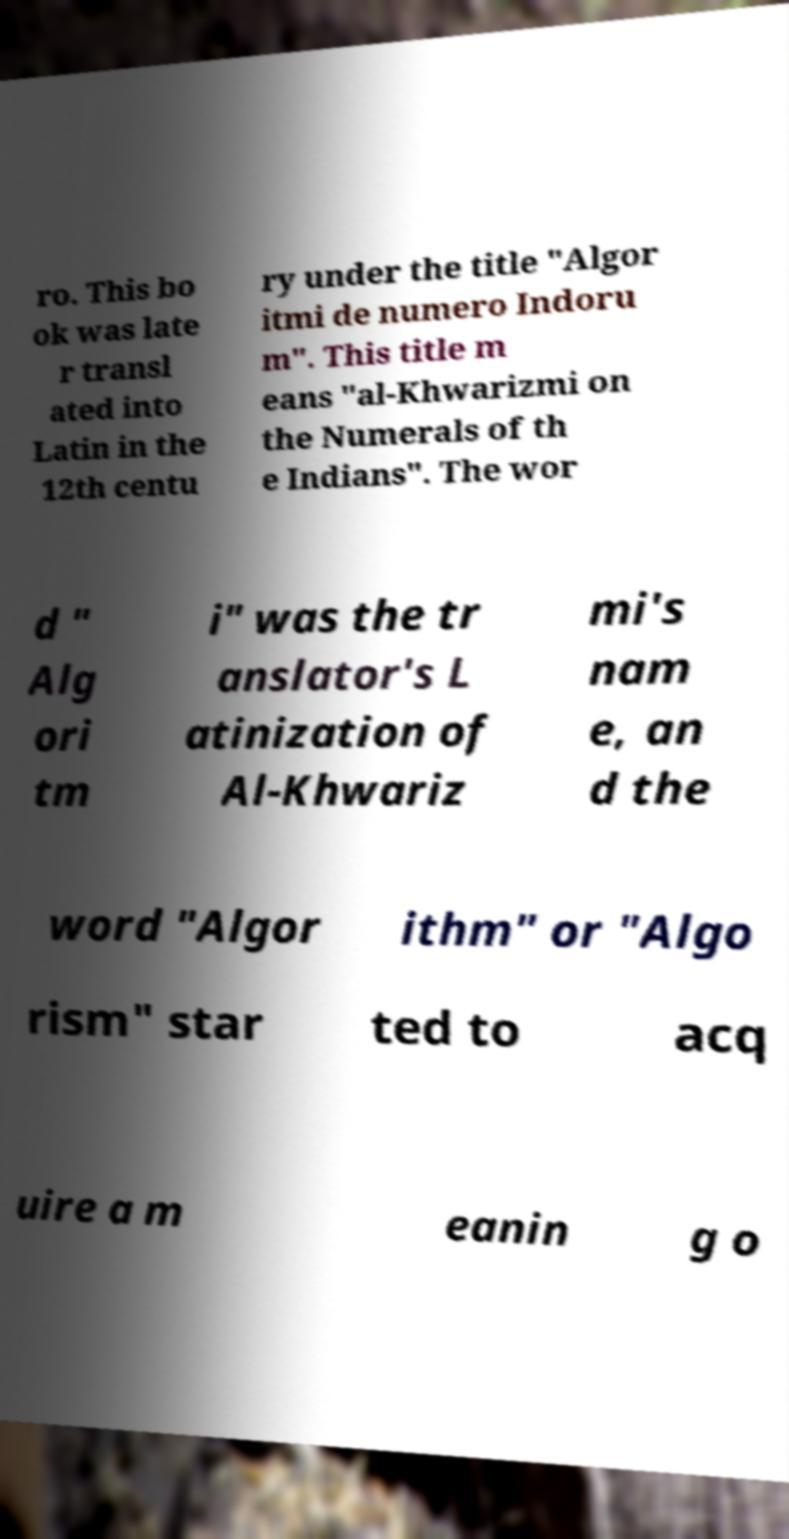There's text embedded in this image that I need extracted. Can you transcribe it verbatim? ro. This bo ok was late r transl ated into Latin in the 12th centu ry under the title "Algor itmi de numero Indoru m". This title m eans "al-Khwarizmi on the Numerals of th e Indians". The wor d " Alg ori tm i" was the tr anslator's L atinization of Al-Khwariz mi's nam e, an d the word "Algor ithm" or "Algo rism" star ted to acq uire a m eanin g o 